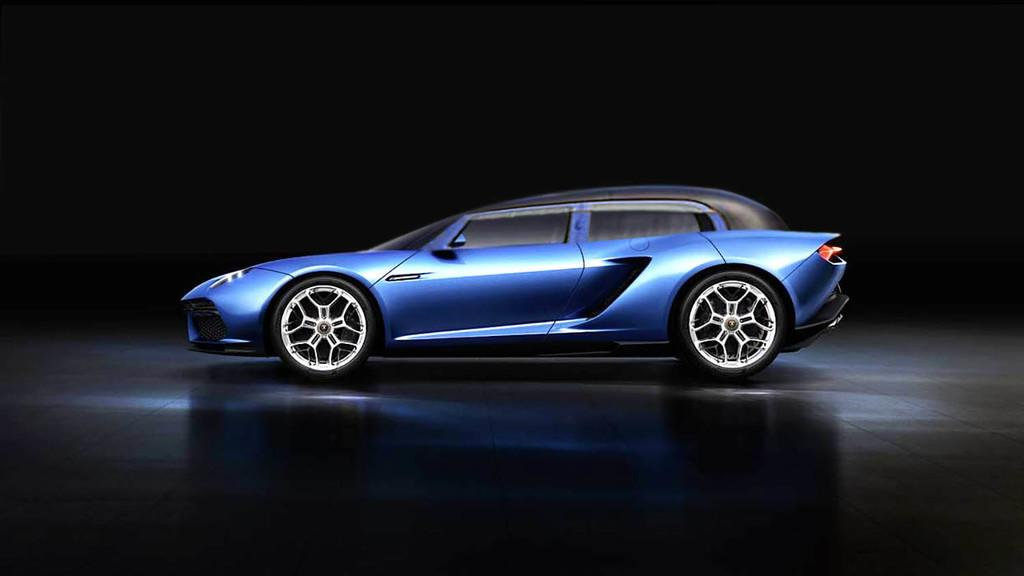What is the main subject of the image? The main subject of the image is a vehicle. Can you describe the color scheme of the vehicle? The vehicle has a blue and black color scheme. What can be observed about the background of the image? The background of the image is dark. What type of stew is being cooked in the vehicle's engine? There is no stew present in the image, and the vehicle's engine is not shown to be cooking anything. 